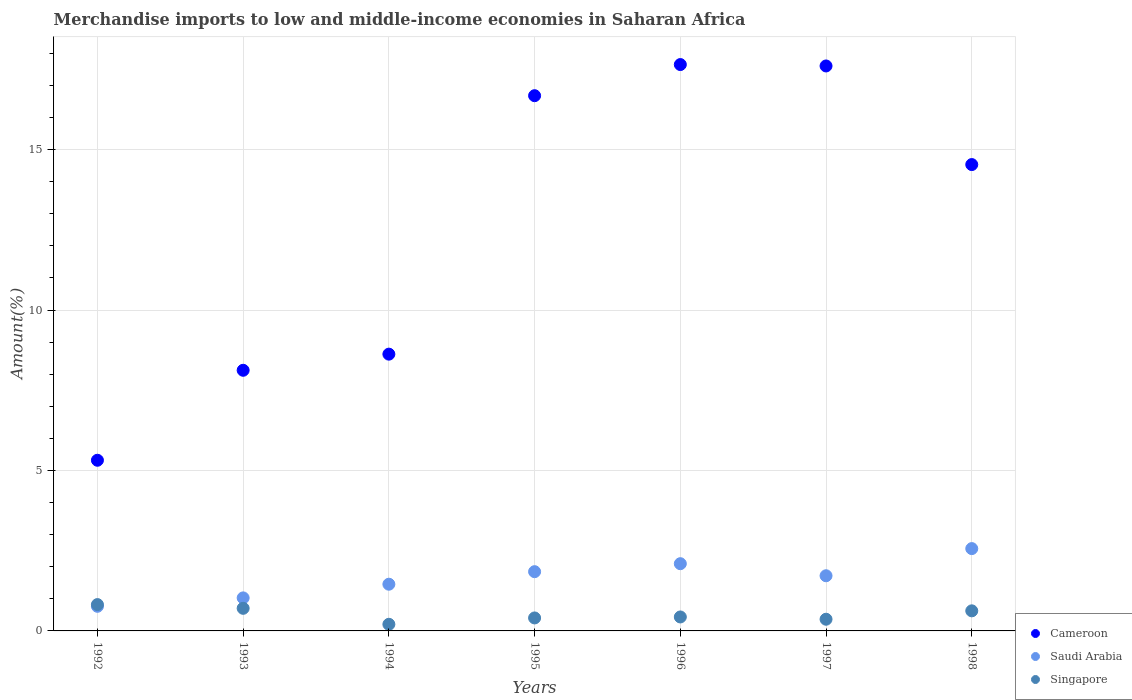Is the number of dotlines equal to the number of legend labels?
Give a very brief answer. Yes. What is the percentage of amount earned from merchandise imports in Singapore in 1995?
Make the answer very short. 0.4. Across all years, what is the maximum percentage of amount earned from merchandise imports in Saudi Arabia?
Give a very brief answer. 2.57. Across all years, what is the minimum percentage of amount earned from merchandise imports in Saudi Arabia?
Provide a short and direct response. 0.77. What is the total percentage of amount earned from merchandise imports in Saudi Arabia in the graph?
Your answer should be compact. 11.48. What is the difference between the percentage of amount earned from merchandise imports in Saudi Arabia in 1992 and that in 1993?
Make the answer very short. -0.26. What is the difference between the percentage of amount earned from merchandise imports in Cameroon in 1993 and the percentage of amount earned from merchandise imports in Saudi Arabia in 1994?
Keep it short and to the point. 6.67. What is the average percentage of amount earned from merchandise imports in Singapore per year?
Make the answer very short. 0.51. In the year 1992, what is the difference between the percentage of amount earned from merchandise imports in Cameroon and percentage of amount earned from merchandise imports in Singapore?
Provide a succinct answer. 4.5. In how many years, is the percentage of amount earned from merchandise imports in Singapore greater than 12 %?
Your response must be concise. 0. What is the ratio of the percentage of amount earned from merchandise imports in Singapore in 1995 to that in 1997?
Offer a terse response. 1.11. Is the percentage of amount earned from merchandise imports in Saudi Arabia in 1993 less than that in 1995?
Your answer should be very brief. Yes. What is the difference between the highest and the second highest percentage of amount earned from merchandise imports in Cameroon?
Provide a short and direct response. 0.04. What is the difference between the highest and the lowest percentage of amount earned from merchandise imports in Saudi Arabia?
Provide a short and direct response. 1.8. Is the sum of the percentage of amount earned from merchandise imports in Singapore in 1993 and 1995 greater than the maximum percentage of amount earned from merchandise imports in Saudi Arabia across all years?
Your answer should be very brief. No. Does the percentage of amount earned from merchandise imports in Singapore monotonically increase over the years?
Keep it short and to the point. No. Is the percentage of amount earned from merchandise imports in Cameroon strictly greater than the percentage of amount earned from merchandise imports in Saudi Arabia over the years?
Provide a short and direct response. Yes. How many dotlines are there?
Offer a very short reply. 3. How many years are there in the graph?
Your answer should be very brief. 7. Does the graph contain any zero values?
Give a very brief answer. No. Does the graph contain grids?
Provide a succinct answer. Yes. Where does the legend appear in the graph?
Your response must be concise. Bottom right. How are the legend labels stacked?
Your answer should be compact. Vertical. What is the title of the graph?
Make the answer very short. Merchandise imports to low and middle-income economies in Saharan Africa. What is the label or title of the Y-axis?
Your response must be concise. Amount(%). What is the Amount(%) in Cameroon in 1992?
Your answer should be very brief. 5.32. What is the Amount(%) of Saudi Arabia in 1992?
Provide a succinct answer. 0.77. What is the Amount(%) of Singapore in 1992?
Provide a succinct answer. 0.82. What is the Amount(%) in Cameroon in 1993?
Your answer should be compact. 8.12. What is the Amount(%) of Saudi Arabia in 1993?
Your answer should be very brief. 1.03. What is the Amount(%) in Singapore in 1993?
Your response must be concise. 0.7. What is the Amount(%) of Cameroon in 1994?
Your answer should be very brief. 8.63. What is the Amount(%) of Saudi Arabia in 1994?
Make the answer very short. 1.46. What is the Amount(%) in Singapore in 1994?
Provide a short and direct response. 0.21. What is the Amount(%) of Cameroon in 1995?
Your response must be concise. 16.68. What is the Amount(%) in Saudi Arabia in 1995?
Offer a very short reply. 1.85. What is the Amount(%) of Singapore in 1995?
Give a very brief answer. 0.4. What is the Amount(%) in Cameroon in 1996?
Offer a very short reply. 17.65. What is the Amount(%) in Saudi Arabia in 1996?
Provide a short and direct response. 2.1. What is the Amount(%) in Singapore in 1996?
Offer a terse response. 0.44. What is the Amount(%) of Cameroon in 1997?
Your answer should be very brief. 17.61. What is the Amount(%) of Saudi Arabia in 1997?
Offer a terse response. 1.72. What is the Amount(%) in Singapore in 1997?
Make the answer very short. 0.36. What is the Amount(%) in Cameroon in 1998?
Your answer should be very brief. 14.53. What is the Amount(%) in Saudi Arabia in 1998?
Provide a short and direct response. 2.57. What is the Amount(%) in Singapore in 1998?
Your answer should be compact. 0.63. Across all years, what is the maximum Amount(%) in Cameroon?
Offer a very short reply. 17.65. Across all years, what is the maximum Amount(%) in Saudi Arabia?
Make the answer very short. 2.57. Across all years, what is the maximum Amount(%) of Singapore?
Offer a very short reply. 0.82. Across all years, what is the minimum Amount(%) in Cameroon?
Provide a succinct answer. 5.32. Across all years, what is the minimum Amount(%) in Saudi Arabia?
Your answer should be very brief. 0.77. Across all years, what is the minimum Amount(%) in Singapore?
Make the answer very short. 0.21. What is the total Amount(%) in Cameroon in the graph?
Offer a terse response. 88.55. What is the total Amount(%) of Saudi Arabia in the graph?
Your answer should be very brief. 11.48. What is the total Amount(%) of Singapore in the graph?
Offer a terse response. 3.56. What is the difference between the Amount(%) in Cameroon in 1992 and that in 1993?
Ensure brevity in your answer.  -2.8. What is the difference between the Amount(%) in Saudi Arabia in 1992 and that in 1993?
Provide a short and direct response. -0.26. What is the difference between the Amount(%) in Singapore in 1992 and that in 1993?
Ensure brevity in your answer.  0.12. What is the difference between the Amount(%) in Cameroon in 1992 and that in 1994?
Keep it short and to the point. -3.31. What is the difference between the Amount(%) of Saudi Arabia in 1992 and that in 1994?
Your answer should be very brief. -0.69. What is the difference between the Amount(%) of Singapore in 1992 and that in 1994?
Your answer should be very brief. 0.61. What is the difference between the Amount(%) of Cameroon in 1992 and that in 1995?
Provide a short and direct response. -11.36. What is the difference between the Amount(%) in Saudi Arabia in 1992 and that in 1995?
Ensure brevity in your answer.  -1.08. What is the difference between the Amount(%) of Singapore in 1992 and that in 1995?
Provide a succinct answer. 0.42. What is the difference between the Amount(%) of Cameroon in 1992 and that in 1996?
Your answer should be compact. -12.33. What is the difference between the Amount(%) in Saudi Arabia in 1992 and that in 1996?
Your answer should be compact. -1.33. What is the difference between the Amount(%) of Singapore in 1992 and that in 1996?
Your response must be concise. 0.39. What is the difference between the Amount(%) in Cameroon in 1992 and that in 1997?
Give a very brief answer. -12.29. What is the difference between the Amount(%) in Saudi Arabia in 1992 and that in 1997?
Give a very brief answer. -0.95. What is the difference between the Amount(%) in Singapore in 1992 and that in 1997?
Give a very brief answer. 0.46. What is the difference between the Amount(%) of Cameroon in 1992 and that in 1998?
Provide a short and direct response. -9.22. What is the difference between the Amount(%) in Saudi Arabia in 1992 and that in 1998?
Make the answer very short. -1.8. What is the difference between the Amount(%) in Singapore in 1992 and that in 1998?
Your answer should be compact. 0.2. What is the difference between the Amount(%) of Cameroon in 1993 and that in 1994?
Provide a short and direct response. -0.5. What is the difference between the Amount(%) in Saudi Arabia in 1993 and that in 1994?
Your answer should be very brief. -0.43. What is the difference between the Amount(%) of Singapore in 1993 and that in 1994?
Provide a short and direct response. 0.5. What is the difference between the Amount(%) of Cameroon in 1993 and that in 1995?
Offer a very short reply. -8.56. What is the difference between the Amount(%) of Saudi Arabia in 1993 and that in 1995?
Your response must be concise. -0.82. What is the difference between the Amount(%) of Singapore in 1993 and that in 1995?
Make the answer very short. 0.3. What is the difference between the Amount(%) of Cameroon in 1993 and that in 1996?
Your answer should be very brief. -9.53. What is the difference between the Amount(%) in Saudi Arabia in 1993 and that in 1996?
Make the answer very short. -1.07. What is the difference between the Amount(%) in Singapore in 1993 and that in 1996?
Your answer should be very brief. 0.27. What is the difference between the Amount(%) in Cameroon in 1993 and that in 1997?
Provide a short and direct response. -9.48. What is the difference between the Amount(%) of Saudi Arabia in 1993 and that in 1997?
Offer a terse response. -0.69. What is the difference between the Amount(%) in Singapore in 1993 and that in 1997?
Provide a succinct answer. 0.34. What is the difference between the Amount(%) of Cameroon in 1993 and that in 1998?
Provide a short and direct response. -6.41. What is the difference between the Amount(%) of Saudi Arabia in 1993 and that in 1998?
Provide a short and direct response. -1.54. What is the difference between the Amount(%) in Singapore in 1993 and that in 1998?
Offer a terse response. 0.08. What is the difference between the Amount(%) of Cameroon in 1994 and that in 1995?
Your response must be concise. -8.06. What is the difference between the Amount(%) in Saudi Arabia in 1994 and that in 1995?
Provide a short and direct response. -0.39. What is the difference between the Amount(%) of Singapore in 1994 and that in 1995?
Offer a terse response. -0.2. What is the difference between the Amount(%) of Cameroon in 1994 and that in 1996?
Give a very brief answer. -9.03. What is the difference between the Amount(%) in Saudi Arabia in 1994 and that in 1996?
Your answer should be compact. -0.64. What is the difference between the Amount(%) of Singapore in 1994 and that in 1996?
Your answer should be very brief. -0.23. What is the difference between the Amount(%) of Cameroon in 1994 and that in 1997?
Keep it short and to the point. -8.98. What is the difference between the Amount(%) of Saudi Arabia in 1994 and that in 1997?
Your response must be concise. -0.26. What is the difference between the Amount(%) of Singapore in 1994 and that in 1997?
Keep it short and to the point. -0.16. What is the difference between the Amount(%) in Cameroon in 1994 and that in 1998?
Give a very brief answer. -5.91. What is the difference between the Amount(%) in Saudi Arabia in 1994 and that in 1998?
Your answer should be very brief. -1.11. What is the difference between the Amount(%) in Singapore in 1994 and that in 1998?
Keep it short and to the point. -0.42. What is the difference between the Amount(%) of Cameroon in 1995 and that in 1996?
Make the answer very short. -0.97. What is the difference between the Amount(%) of Saudi Arabia in 1995 and that in 1996?
Provide a succinct answer. -0.25. What is the difference between the Amount(%) of Singapore in 1995 and that in 1996?
Your response must be concise. -0.03. What is the difference between the Amount(%) in Cameroon in 1995 and that in 1997?
Make the answer very short. -0.93. What is the difference between the Amount(%) of Saudi Arabia in 1995 and that in 1997?
Provide a short and direct response. 0.13. What is the difference between the Amount(%) of Singapore in 1995 and that in 1997?
Offer a terse response. 0.04. What is the difference between the Amount(%) in Cameroon in 1995 and that in 1998?
Make the answer very short. 2.15. What is the difference between the Amount(%) in Saudi Arabia in 1995 and that in 1998?
Provide a succinct answer. -0.72. What is the difference between the Amount(%) in Singapore in 1995 and that in 1998?
Offer a terse response. -0.22. What is the difference between the Amount(%) of Cameroon in 1996 and that in 1997?
Keep it short and to the point. 0.04. What is the difference between the Amount(%) in Saudi Arabia in 1996 and that in 1997?
Provide a short and direct response. 0.38. What is the difference between the Amount(%) of Singapore in 1996 and that in 1997?
Make the answer very short. 0.07. What is the difference between the Amount(%) of Cameroon in 1996 and that in 1998?
Ensure brevity in your answer.  3.12. What is the difference between the Amount(%) of Saudi Arabia in 1996 and that in 1998?
Provide a short and direct response. -0.47. What is the difference between the Amount(%) of Singapore in 1996 and that in 1998?
Provide a succinct answer. -0.19. What is the difference between the Amount(%) in Cameroon in 1997 and that in 1998?
Give a very brief answer. 3.07. What is the difference between the Amount(%) in Saudi Arabia in 1997 and that in 1998?
Offer a terse response. -0.85. What is the difference between the Amount(%) of Singapore in 1997 and that in 1998?
Offer a very short reply. -0.26. What is the difference between the Amount(%) in Cameroon in 1992 and the Amount(%) in Saudi Arabia in 1993?
Your response must be concise. 4.29. What is the difference between the Amount(%) of Cameroon in 1992 and the Amount(%) of Singapore in 1993?
Provide a short and direct response. 4.61. What is the difference between the Amount(%) in Saudi Arabia in 1992 and the Amount(%) in Singapore in 1993?
Offer a very short reply. 0.06. What is the difference between the Amount(%) in Cameroon in 1992 and the Amount(%) in Saudi Arabia in 1994?
Provide a succinct answer. 3.86. What is the difference between the Amount(%) in Cameroon in 1992 and the Amount(%) in Singapore in 1994?
Offer a very short reply. 5.11. What is the difference between the Amount(%) of Saudi Arabia in 1992 and the Amount(%) of Singapore in 1994?
Your response must be concise. 0.56. What is the difference between the Amount(%) in Cameroon in 1992 and the Amount(%) in Saudi Arabia in 1995?
Give a very brief answer. 3.47. What is the difference between the Amount(%) of Cameroon in 1992 and the Amount(%) of Singapore in 1995?
Keep it short and to the point. 4.91. What is the difference between the Amount(%) of Saudi Arabia in 1992 and the Amount(%) of Singapore in 1995?
Ensure brevity in your answer.  0.36. What is the difference between the Amount(%) of Cameroon in 1992 and the Amount(%) of Saudi Arabia in 1996?
Provide a short and direct response. 3.22. What is the difference between the Amount(%) of Cameroon in 1992 and the Amount(%) of Singapore in 1996?
Keep it short and to the point. 4.88. What is the difference between the Amount(%) of Saudi Arabia in 1992 and the Amount(%) of Singapore in 1996?
Your answer should be compact. 0.33. What is the difference between the Amount(%) of Cameroon in 1992 and the Amount(%) of Saudi Arabia in 1997?
Offer a terse response. 3.6. What is the difference between the Amount(%) of Cameroon in 1992 and the Amount(%) of Singapore in 1997?
Make the answer very short. 4.96. What is the difference between the Amount(%) of Saudi Arabia in 1992 and the Amount(%) of Singapore in 1997?
Give a very brief answer. 0.4. What is the difference between the Amount(%) of Cameroon in 1992 and the Amount(%) of Saudi Arabia in 1998?
Make the answer very short. 2.75. What is the difference between the Amount(%) in Cameroon in 1992 and the Amount(%) in Singapore in 1998?
Your answer should be compact. 4.69. What is the difference between the Amount(%) in Saudi Arabia in 1992 and the Amount(%) in Singapore in 1998?
Offer a terse response. 0.14. What is the difference between the Amount(%) of Cameroon in 1993 and the Amount(%) of Saudi Arabia in 1994?
Give a very brief answer. 6.67. What is the difference between the Amount(%) of Cameroon in 1993 and the Amount(%) of Singapore in 1994?
Provide a short and direct response. 7.92. What is the difference between the Amount(%) in Saudi Arabia in 1993 and the Amount(%) in Singapore in 1994?
Your answer should be compact. 0.82. What is the difference between the Amount(%) of Cameroon in 1993 and the Amount(%) of Saudi Arabia in 1995?
Ensure brevity in your answer.  6.28. What is the difference between the Amount(%) of Cameroon in 1993 and the Amount(%) of Singapore in 1995?
Your response must be concise. 7.72. What is the difference between the Amount(%) of Saudi Arabia in 1993 and the Amount(%) of Singapore in 1995?
Keep it short and to the point. 0.62. What is the difference between the Amount(%) of Cameroon in 1993 and the Amount(%) of Saudi Arabia in 1996?
Your answer should be very brief. 6.03. What is the difference between the Amount(%) in Cameroon in 1993 and the Amount(%) in Singapore in 1996?
Your response must be concise. 7.69. What is the difference between the Amount(%) of Saudi Arabia in 1993 and the Amount(%) of Singapore in 1996?
Your answer should be compact. 0.59. What is the difference between the Amount(%) in Cameroon in 1993 and the Amount(%) in Saudi Arabia in 1997?
Your answer should be compact. 6.4. What is the difference between the Amount(%) in Cameroon in 1993 and the Amount(%) in Singapore in 1997?
Offer a terse response. 7.76. What is the difference between the Amount(%) of Saudi Arabia in 1993 and the Amount(%) of Singapore in 1997?
Keep it short and to the point. 0.67. What is the difference between the Amount(%) in Cameroon in 1993 and the Amount(%) in Saudi Arabia in 1998?
Keep it short and to the point. 5.56. What is the difference between the Amount(%) in Cameroon in 1993 and the Amount(%) in Singapore in 1998?
Offer a very short reply. 7.5. What is the difference between the Amount(%) of Saudi Arabia in 1993 and the Amount(%) of Singapore in 1998?
Offer a terse response. 0.4. What is the difference between the Amount(%) in Cameroon in 1994 and the Amount(%) in Saudi Arabia in 1995?
Offer a very short reply. 6.78. What is the difference between the Amount(%) of Cameroon in 1994 and the Amount(%) of Singapore in 1995?
Make the answer very short. 8.22. What is the difference between the Amount(%) of Saudi Arabia in 1994 and the Amount(%) of Singapore in 1995?
Your answer should be compact. 1.05. What is the difference between the Amount(%) in Cameroon in 1994 and the Amount(%) in Saudi Arabia in 1996?
Your answer should be very brief. 6.53. What is the difference between the Amount(%) of Cameroon in 1994 and the Amount(%) of Singapore in 1996?
Offer a very short reply. 8.19. What is the difference between the Amount(%) of Saudi Arabia in 1994 and the Amount(%) of Singapore in 1996?
Ensure brevity in your answer.  1.02. What is the difference between the Amount(%) of Cameroon in 1994 and the Amount(%) of Saudi Arabia in 1997?
Your response must be concise. 6.91. What is the difference between the Amount(%) of Cameroon in 1994 and the Amount(%) of Singapore in 1997?
Offer a very short reply. 8.26. What is the difference between the Amount(%) of Saudi Arabia in 1994 and the Amount(%) of Singapore in 1997?
Provide a short and direct response. 1.09. What is the difference between the Amount(%) of Cameroon in 1994 and the Amount(%) of Saudi Arabia in 1998?
Your answer should be very brief. 6.06. What is the difference between the Amount(%) of Cameroon in 1994 and the Amount(%) of Singapore in 1998?
Provide a succinct answer. 8. What is the difference between the Amount(%) of Saudi Arabia in 1994 and the Amount(%) of Singapore in 1998?
Your answer should be very brief. 0.83. What is the difference between the Amount(%) of Cameroon in 1995 and the Amount(%) of Saudi Arabia in 1996?
Your response must be concise. 14.59. What is the difference between the Amount(%) in Cameroon in 1995 and the Amount(%) in Singapore in 1996?
Your answer should be very brief. 16.25. What is the difference between the Amount(%) of Saudi Arabia in 1995 and the Amount(%) of Singapore in 1996?
Make the answer very short. 1.41. What is the difference between the Amount(%) in Cameroon in 1995 and the Amount(%) in Saudi Arabia in 1997?
Your response must be concise. 14.96. What is the difference between the Amount(%) of Cameroon in 1995 and the Amount(%) of Singapore in 1997?
Give a very brief answer. 16.32. What is the difference between the Amount(%) of Saudi Arabia in 1995 and the Amount(%) of Singapore in 1997?
Keep it short and to the point. 1.48. What is the difference between the Amount(%) in Cameroon in 1995 and the Amount(%) in Saudi Arabia in 1998?
Your response must be concise. 14.12. What is the difference between the Amount(%) in Cameroon in 1995 and the Amount(%) in Singapore in 1998?
Make the answer very short. 16.06. What is the difference between the Amount(%) in Saudi Arabia in 1995 and the Amount(%) in Singapore in 1998?
Your answer should be compact. 1.22. What is the difference between the Amount(%) in Cameroon in 1996 and the Amount(%) in Saudi Arabia in 1997?
Provide a short and direct response. 15.93. What is the difference between the Amount(%) in Cameroon in 1996 and the Amount(%) in Singapore in 1997?
Offer a very short reply. 17.29. What is the difference between the Amount(%) of Saudi Arabia in 1996 and the Amount(%) of Singapore in 1997?
Your answer should be compact. 1.73. What is the difference between the Amount(%) of Cameroon in 1996 and the Amount(%) of Saudi Arabia in 1998?
Your answer should be compact. 15.09. What is the difference between the Amount(%) of Cameroon in 1996 and the Amount(%) of Singapore in 1998?
Give a very brief answer. 17.03. What is the difference between the Amount(%) of Saudi Arabia in 1996 and the Amount(%) of Singapore in 1998?
Make the answer very short. 1.47. What is the difference between the Amount(%) in Cameroon in 1997 and the Amount(%) in Saudi Arabia in 1998?
Offer a terse response. 15.04. What is the difference between the Amount(%) in Cameroon in 1997 and the Amount(%) in Singapore in 1998?
Provide a succinct answer. 16.98. What is the difference between the Amount(%) in Saudi Arabia in 1997 and the Amount(%) in Singapore in 1998?
Provide a succinct answer. 1.09. What is the average Amount(%) in Cameroon per year?
Offer a terse response. 12.65. What is the average Amount(%) of Saudi Arabia per year?
Offer a very short reply. 1.64. What is the average Amount(%) of Singapore per year?
Offer a terse response. 0.51. In the year 1992, what is the difference between the Amount(%) in Cameroon and Amount(%) in Saudi Arabia?
Your answer should be very brief. 4.55. In the year 1992, what is the difference between the Amount(%) in Cameroon and Amount(%) in Singapore?
Provide a succinct answer. 4.5. In the year 1992, what is the difference between the Amount(%) in Saudi Arabia and Amount(%) in Singapore?
Offer a very short reply. -0.05. In the year 1993, what is the difference between the Amount(%) in Cameroon and Amount(%) in Saudi Arabia?
Offer a terse response. 7.09. In the year 1993, what is the difference between the Amount(%) in Cameroon and Amount(%) in Singapore?
Provide a succinct answer. 7.42. In the year 1993, what is the difference between the Amount(%) in Saudi Arabia and Amount(%) in Singapore?
Keep it short and to the point. 0.33. In the year 1994, what is the difference between the Amount(%) of Cameroon and Amount(%) of Saudi Arabia?
Ensure brevity in your answer.  7.17. In the year 1994, what is the difference between the Amount(%) of Cameroon and Amount(%) of Singapore?
Make the answer very short. 8.42. In the year 1994, what is the difference between the Amount(%) in Saudi Arabia and Amount(%) in Singapore?
Offer a very short reply. 1.25. In the year 1995, what is the difference between the Amount(%) in Cameroon and Amount(%) in Saudi Arabia?
Offer a very short reply. 14.84. In the year 1995, what is the difference between the Amount(%) of Cameroon and Amount(%) of Singapore?
Keep it short and to the point. 16.28. In the year 1995, what is the difference between the Amount(%) in Saudi Arabia and Amount(%) in Singapore?
Your answer should be compact. 1.44. In the year 1996, what is the difference between the Amount(%) of Cameroon and Amount(%) of Saudi Arabia?
Provide a short and direct response. 15.56. In the year 1996, what is the difference between the Amount(%) of Cameroon and Amount(%) of Singapore?
Your answer should be very brief. 17.22. In the year 1996, what is the difference between the Amount(%) in Saudi Arabia and Amount(%) in Singapore?
Your response must be concise. 1.66. In the year 1997, what is the difference between the Amount(%) of Cameroon and Amount(%) of Saudi Arabia?
Provide a short and direct response. 15.89. In the year 1997, what is the difference between the Amount(%) of Cameroon and Amount(%) of Singapore?
Ensure brevity in your answer.  17.24. In the year 1997, what is the difference between the Amount(%) in Saudi Arabia and Amount(%) in Singapore?
Make the answer very short. 1.36. In the year 1998, what is the difference between the Amount(%) of Cameroon and Amount(%) of Saudi Arabia?
Offer a terse response. 11.97. In the year 1998, what is the difference between the Amount(%) of Cameroon and Amount(%) of Singapore?
Ensure brevity in your answer.  13.91. In the year 1998, what is the difference between the Amount(%) in Saudi Arabia and Amount(%) in Singapore?
Your answer should be very brief. 1.94. What is the ratio of the Amount(%) in Cameroon in 1992 to that in 1993?
Your response must be concise. 0.65. What is the ratio of the Amount(%) in Saudi Arabia in 1992 to that in 1993?
Keep it short and to the point. 0.75. What is the ratio of the Amount(%) in Singapore in 1992 to that in 1993?
Your response must be concise. 1.17. What is the ratio of the Amount(%) in Cameroon in 1992 to that in 1994?
Provide a succinct answer. 0.62. What is the ratio of the Amount(%) in Saudi Arabia in 1992 to that in 1994?
Ensure brevity in your answer.  0.53. What is the ratio of the Amount(%) of Singapore in 1992 to that in 1994?
Provide a succinct answer. 3.98. What is the ratio of the Amount(%) of Cameroon in 1992 to that in 1995?
Give a very brief answer. 0.32. What is the ratio of the Amount(%) of Saudi Arabia in 1992 to that in 1995?
Ensure brevity in your answer.  0.42. What is the ratio of the Amount(%) in Singapore in 1992 to that in 1995?
Make the answer very short. 2.03. What is the ratio of the Amount(%) of Cameroon in 1992 to that in 1996?
Your answer should be compact. 0.3. What is the ratio of the Amount(%) of Saudi Arabia in 1992 to that in 1996?
Make the answer very short. 0.37. What is the ratio of the Amount(%) in Singapore in 1992 to that in 1996?
Give a very brief answer. 1.89. What is the ratio of the Amount(%) in Cameroon in 1992 to that in 1997?
Your answer should be very brief. 0.3. What is the ratio of the Amount(%) in Saudi Arabia in 1992 to that in 1997?
Keep it short and to the point. 0.45. What is the ratio of the Amount(%) of Singapore in 1992 to that in 1997?
Make the answer very short. 2.25. What is the ratio of the Amount(%) of Cameroon in 1992 to that in 1998?
Provide a succinct answer. 0.37. What is the ratio of the Amount(%) of Saudi Arabia in 1992 to that in 1998?
Offer a terse response. 0.3. What is the ratio of the Amount(%) in Singapore in 1992 to that in 1998?
Your answer should be compact. 1.31. What is the ratio of the Amount(%) in Cameroon in 1993 to that in 1994?
Ensure brevity in your answer.  0.94. What is the ratio of the Amount(%) of Saudi Arabia in 1993 to that in 1994?
Offer a very short reply. 0.71. What is the ratio of the Amount(%) of Singapore in 1993 to that in 1994?
Your answer should be very brief. 3.41. What is the ratio of the Amount(%) of Cameroon in 1993 to that in 1995?
Your answer should be very brief. 0.49. What is the ratio of the Amount(%) in Saudi Arabia in 1993 to that in 1995?
Offer a terse response. 0.56. What is the ratio of the Amount(%) in Singapore in 1993 to that in 1995?
Provide a succinct answer. 1.74. What is the ratio of the Amount(%) of Cameroon in 1993 to that in 1996?
Make the answer very short. 0.46. What is the ratio of the Amount(%) of Saudi Arabia in 1993 to that in 1996?
Your response must be concise. 0.49. What is the ratio of the Amount(%) in Singapore in 1993 to that in 1996?
Your answer should be compact. 1.62. What is the ratio of the Amount(%) of Cameroon in 1993 to that in 1997?
Make the answer very short. 0.46. What is the ratio of the Amount(%) in Saudi Arabia in 1993 to that in 1997?
Keep it short and to the point. 0.6. What is the ratio of the Amount(%) in Singapore in 1993 to that in 1997?
Your answer should be compact. 1.93. What is the ratio of the Amount(%) of Cameroon in 1993 to that in 1998?
Your answer should be compact. 0.56. What is the ratio of the Amount(%) of Saudi Arabia in 1993 to that in 1998?
Offer a terse response. 0.4. What is the ratio of the Amount(%) of Singapore in 1993 to that in 1998?
Offer a terse response. 1.13. What is the ratio of the Amount(%) of Cameroon in 1994 to that in 1995?
Ensure brevity in your answer.  0.52. What is the ratio of the Amount(%) in Saudi Arabia in 1994 to that in 1995?
Your answer should be very brief. 0.79. What is the ratio of the Amount(%) in Singapore in 1994 to that in 1995?
Keep it short and to the point. 0.51. What is the ratio of the Amount(%) in Cameroon in 1994 to that in 1996?
Keep it short and to the point. 0.49. What is the ratio of the Amount(%) in Saudi Arabia in 1994 to that in 1996?
Your answer should be very brief. 0.69. What is the ratio of the Amount(%) of Singapore in 1994 to that in 1996?
Your answer should be very brief. 0.47. What is the ratio of the Amount(%) of Cameroon in 1994 to that in 1997?
Keep it short and to the point. 0.49. What is the ratio of the Amount(%) in Saudi Arabia in 1994 to that in 1997?
Your answer should be compact. 0.85. What is the ratio of the Amount(%) in Singapore in 1994 to that in 1997?
Offer a very short reply. 0.57. What is the ratio of the Amount(%) in Cameroon in 1994 to that in 1998?
Provide a short and direct response. 0.59. What is the ratio of the Amount(%) of Saudi Arabia in 1994 to that in 1998?
Keep it short and to the point. 0.57. What is the ratio of the Amount(%) in Singapore in 1994 to that in 1998?
Offer a very short reply. 0.33. What is the ratio of the Amount(%) in Cameroon in 1995 to that in 1996?
Give a very brief answer. 0.94. What is the ratio of the Amount(%) in Saudi Arabia in 1995 to that in 1996?
Provide a succinct answer. 0.88. What is the ratio of the Amount(%) in Singapore in 1995 to that in 1996?
Offer a terse response. 0.93. What is the ratio of the Amount(%) in Saudi Arabia in 1995 to that in 1997?
Your answer should be compact. 1.07. What is the ratio of the Amount(%) of Cameroon in 1995 to that in 1998?
Keep it short and to the point. 1.15. What is the ratio of the Amount(%) in Saudi Arabia in 1995 to that in 1998?
Offer a terse response. 0.72. What is the ratio of the Amount(%) in Singapore in 1995 to that in 1998?
Make the answer very short. 0.65. What is the ratio of the Amount(%) in Saudi Arabia in 1996 to that in 1997?
Provide a succinct answer. 1.22. What is the ratio of the Amount(%) in Singapore in 1996 to that in 1997?
Provide a succinct answer. 1.19. What is the ratio of the Amount(%) of Cameroon in 1996 to that in 1998?
Offer a terse response. 1.21. What is the ratio of the Amount(%) in Saudi Arabia in 1996 to that in 1998?
Provide a succinct answer. 0.82. What is the ratio of the Amount(%) of Singapore in 1996 to that in 1998?
Offer a terse response. 0.7. What is the ratio of the Amount(%) in Cameroon in 1997 to that in 1998?
Your answer should be very brief. 1.21. What is the ratio of the Amount(%) in Saudi Arabia in 1997 to that in 1998?
Your response must be concise. 0.67. What is the ratio of the Amount(%) of Singapore in 1997 to that in 1998?
Offer a very short reply. 0.58. What is the difference between the highest and the second highest Amount(%) of Cameroon?
Offer a very short reply. 0.04. What is the difference between the highest and the second highest Amount(%) of Saudi Arabia?
Ensure brevity in your answer.  0.47. What is the difference between the highest and the second highest Amount(%) in Singapore?
Your answer should be very brief. 0.12. What is the difference between the highest and the lowest Amount(%) in Cameroon?
Offer a terse response. 12.33. What is the difference between the highest and the lowest Amount(%) in Saudi Arabia?
Provide a short and direct response. 1.8. What is the difference between the highest and the lowest Amount(%) of Singapore?
Offer a very short reply. 0.61. 